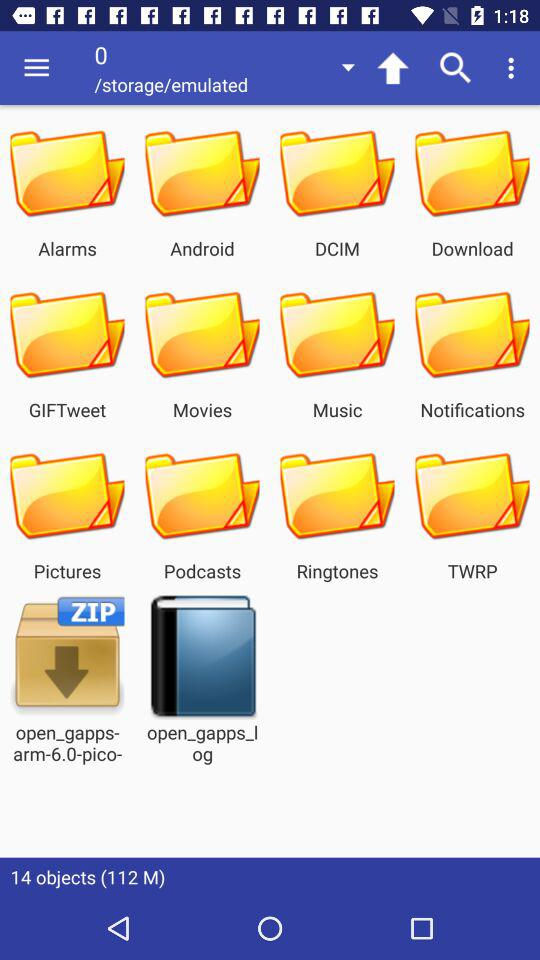How many objects are there? There are 14 objects. 